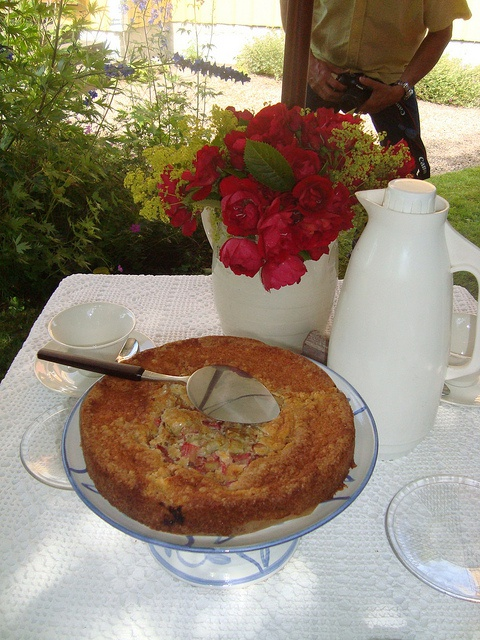Describe the objects in this image and their specific colors. I can see bowl in olive, brown, maroon, and darkgray tones, potted plant in olive, maroon, darkgray, and brown tones, people in olive, maroon, black, and gray tones, vase in olive, darkgray, and gray tones, and spoon in olive, gray, and black tones in this image. 